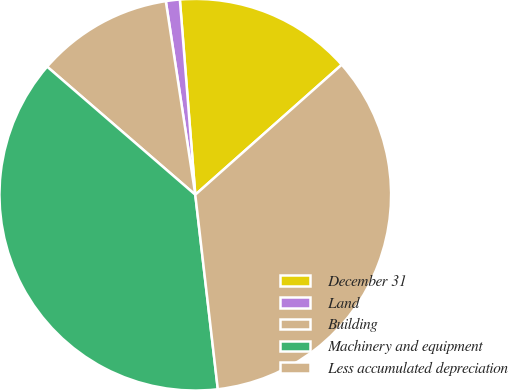<chart> <loc_0><loc_0><loc_500><loc_500><pie_chart><fcel>December 31<fcel>Land<fcel>Building<fcel>Machinery and equipment<fcel>Less accumulated depreciation<nl><fcel>14.7%<fcel>1.15%<fcel>11.25%<fcel>38.18%<fcel>34.72%<nl></chart> 